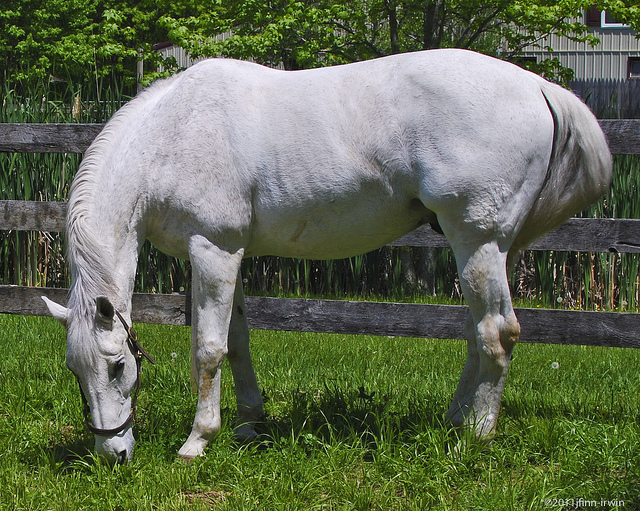Can you tell if it's morning, afternoon, or evening in the picture? Based on the brightness and shadows in the image, it appears to be either morning or afternoon. The light is bright and the shadows aren't very long, suggesting it's not evening yet. What kind of mood does the lighting create? The bright lighting in the image creates a serene and peaceful mood. The clear, vivid lighting enhances the sense of tranquility and calm, making the scene appear naturally beautiful and soothing. Do you think this image could be used for educational purposes? If so, how? Yes, this image could certainly be used for educational purposes. It can be used to teach children about animals, particularly horses, including their behaviors, habitats, and the importance of grazing. Additionally, it can be used in a lesson about ecosystems and the interrelationship between different plant and animal species in a pasture. The image can also foster discussions about the environmental benefits of maintaining natural landscapes and the care needed for domestic animals in similar settings. 